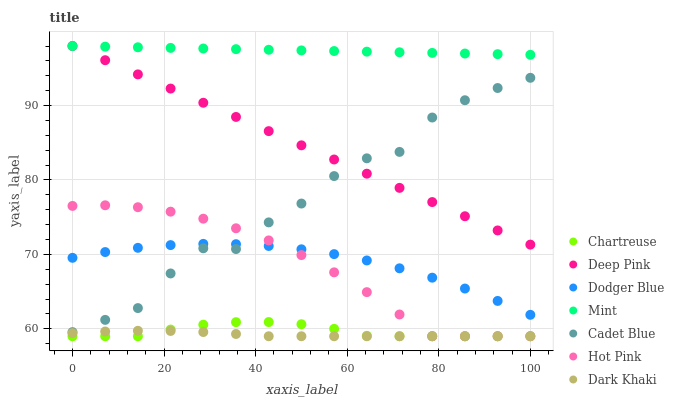Does Dark Khaki have the minimum area under the curve?
Answer yes or no. Yes. Does Mint have the maximum area under the curve?
Answer yes or no. Yes. Does Hot Pink have the minimum area under the curve?
Answer yes or no. No. Does Hot Pink have the maximum area under the curve?
Answer yes or no. No. Is Deep Pink the smoothest?
Answer yes or no. Yes. Is Cadet Blue the roughest?
Answer yes or no. Yes. Is Hot Pink the smoothest?
Answer yes or no. No. Is Hot Pink the roughest?
Answer yes or no. No. Does Hot Pink have the lowest value?
Answer yes or no. Yes. Does Deep Pink have the lowest value?
Answer yes or no. No. Does Mint have the highest value?
Answer yes or no. Yes. Does Hot Pink have the highest value?
Answer yes or no. No. Is Dodger Blue less than Deep Pink?
Answer yes or no. Yes. Is Deep Pink greater than Chartreuse?
Answer yes or no. Yes. Does Deep Pink intersect Mint?
Answer yes or no. Yes. Is Deep Pink less than Mint?
Answer yes or no. No. Is Deep Pink greater than Mint?
Answer yes or no. No. Does Dodger Blue intersect Deep Pink?
Answer yes or no. No. 